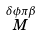Convert formula to latex. <formula><loc_0><loc_0><loc_500><loc_500>\stackrel { \delta \phi \pi \beta } { M }</formula> 